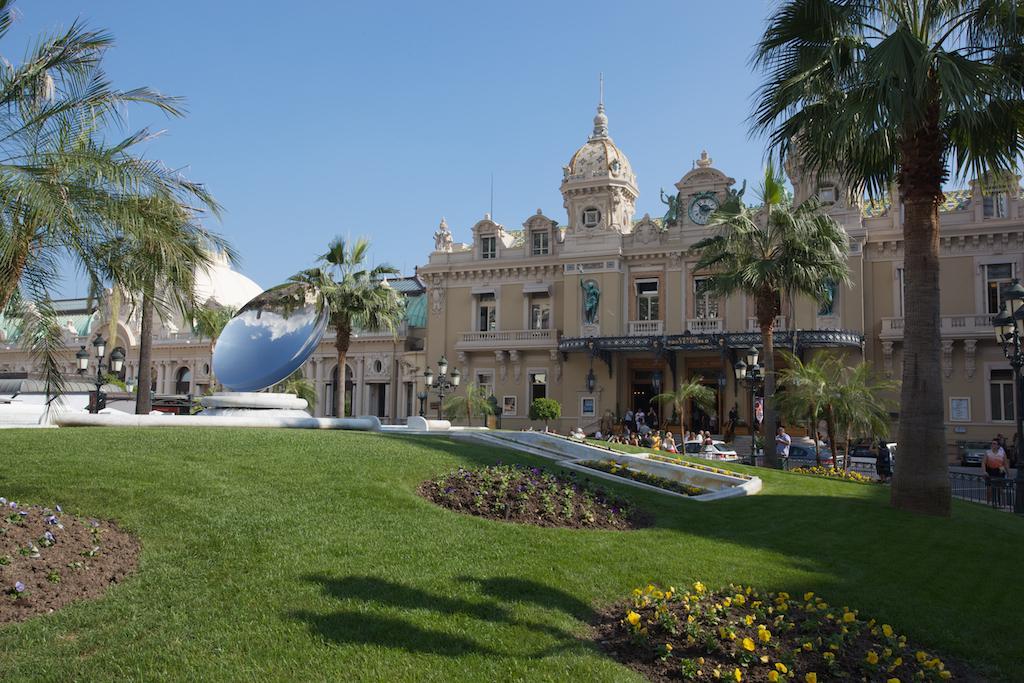Can you describe this image briefly? In this image in the front there's grass on the ground and there are flowers. In the background there are buildings, trees, persons and poles. 